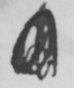Please transcribe the handwritten text in this image. <gap/> 